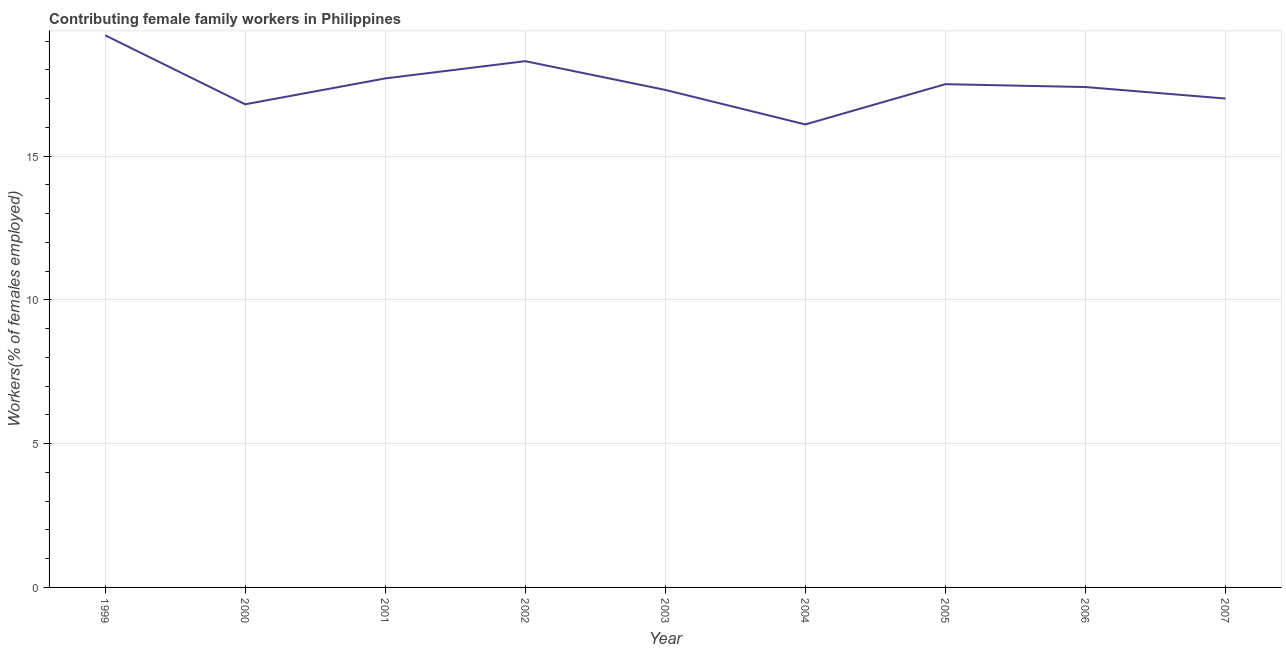What is the contributing female family workers in 2003?
Your answer should be compact. 17.3. Across all years, what is the maximum contributing female family workers?
Provide a short and direct response. 19.2. Across all years, what is the minimum contributing female family workers?
Keep it short and to the point. 16.1. What is the sum of the contributing female family workers?
Offer a very short reply. 157.3. What is the difference between the contributing female family workers in 2001 and 2004?
Offer a very short reply. 1.6. What is the average contributing female family workers per year?
Keep it short and to the point. 17.48. What is the median contributing female family workers?
Your response must be concise. 17.4. In how many years, is the contributing female family workers greater than 2 %?
Provide a short and direct response. 9. What is the ratio of the contributing female family workers in 2000 to that in 2007?
Your answer should be very brief. 0.99. Is the difference between the contributing female family workers in 2001 and 2004 greater than the difference between any two years?
Keep it short and to the point. No. What is the difference between the highest and the second highest contributing female family workers?
Your answer should be compact. 0.9. Is the sum of the contributing female family workers in 1999 and 2001 greater than the maximum contributing female family workers across all years?
Give a very brief answer. Yes. What is the difference between the highest and the lowest contributing female family workers?
Offer a terse response. 3.1. Are the values on the major ticks of Y-axis written in scientific E-notation?
Your answer should be very brief. No. Does the graph contain grids?
Your answer should be very brief. Yes. What is the title of the graph?
Offer a very short reply. Contributing female family workers in Philippines. What is the label or title of the X-axis?
Ensure brevity in your answer.  Year. What is the label or title of the Y-axis?
Ensure brevity in your answer.  Workers(% of females employed). What is the Workers(% of females employed) in 1999?
Make the answer very short. 19.2. What is the Workers(% of females employed) of 2000?
Keep it short and to the point. 16.8. What is the Workers(% of females employed) of 2001?
Ensure brevity in your answer.  17.7. What is the Workers(% of females employed) of 2002?
Ensure brevity in your answer.  18.3. What is the Workers(% of females employed) in 2003?
Offer a very short reply. 17.3. What is the Workers(% of females employed) in 2004?
Ensure brevity in your answer.  16.1. What is the Workers(% of females employed) in 2006?
Keep it short and to the point. 17.4. What is the Workers(% of females employed) of 2007?
Your response must be concise. 17. What is the difference between the Workers(% of females employed) in 1999 and 2000?
Provide a short and direct response. 2.4. What is the difference between the Workers(% of females employed) in 1999 and 2003?
Make the answer very short. 1.9. What is the difference between the Workers(% of females employed) in 1999 and 2005?
Provide a short and direct response. 1.7. What is the difference between the Workers(% of females employed) in 1999 and 2006?
Give a very brief answer. 1.8. What is the difference between the Workers(% of females employed) in 2000 and 2001?
Keep it short and to the point. -0.9. What is the difference between the Workers(% of females employed) in 2000 and 2002?
Ensure brevity in your answer.  -1.5. What is the difference between the Workers(% of females employed) in 2000 and 2003?
Offer a very short reply. -0.5. What is the difference between the Workers(% of females employed) in 2001 and 2006?
Give a very brief answer. 0.3. What is the difference between the Workers(% of females employed) in 2001 and 2007?
Your response must be concise. 0.7. What is the difference between the Workers(% of females employed) in 2002 and 2004?
Your answer should be very brief. 2.2. What is the difference between the Workers(% of females employed) in 2002 and 2006?
Offer a terse response. 0.9. What is the difference between the Workers(% of females employed) in 2002 and 2007?
Keep it short and to the point. 1.3. What is the difference between the Workers(% of females employed) in 2003 and 2005?
Make the answer very short. -0.2. What is the difference between the Workers(% of females employed) in 2003 and 2006?
Offer a terse response. -0.1. What is the difference between the Workers(% of females employed) in 2003 and 2007?
Make the answer very short. 0.3. What is the difference between the Workers(% of females employed) in 2004 and 2005?
Offer a terse response. -1.4. What is the difference between the Workers(% of females employed) in 2005 and 2006?
Your answer should be very brief. 0.1. What is the difference between the Workers(% of females employed) in 2006 and 2007?
Keep it short and to the point. 0.4. What is the ratio of the Workers(% of females employed) in 1999 to that in 2000?
Your answer should be very brief. 1.14. What is the ratio of the Workers(% of females employed) in 1999 to that in 2001?
Your answer should be compact. 1.08. What is the ratio of the Workers(% of females employed) in 1999 to that in 2002?
Your answer should be compact. 1.05. What is the ratio of the Workers(% of females employed) in 1999 to that in 2003?
Make the answer very short. 1.11. What is the ratio of the Workers(% of females employed) in 1999 to that in 2004?
Ensure brevity in your answer.  1.19. What is the ratio of the Workers(% of females employed) in 1999 to that in 2005?
Make the answer very short. 1.1. What is the ratio of the Workers(% of females employed) in 1999 to that in 2006?
Give a very brief answer. 1.1. What is the ratio of the Workers(% of females employed) in 1999 to that in 2007?
Offer a very short reply. 1.13. What is the ratio of the Workers(% of females employed) in 2000 to that in 2001?
Offer a very short reply. 0.95. What is the ratio of the Workers(% of females employed) in 2000 to that in 2002?
Provide a short and direct response. 0.92. What is the ratio of the Workers(% of females employed) in 2000 to that in 2003?
Give a very brief answer. 0.97. What is the ratio of the Workers(% of females employed) in 2000 to that in 2004?
Provide a succinct answer. 1.04. What is the ratio of the Workers(% of females employed) in 2001 to that in 2004?
Offer a terse response. 1.1. What is the ratio of the Workers(% of females employed) in 2001 to that in 2006?
Give a very brief answer. 1.02. What is the ratio of the Workers(% of females employed) in 2001 to that in 2007?
Offer a terse response. 1.04. What is the ratio of the Workers(% of females employed) in 2002 to that in 2003?
Offer a terse response. 1.06. What is the ratio of the Workers(% of females employed) in 2002 to that in 2004?
Your answer should be compact. 1.14. What is the ratio of the Workers(% of females employed) in 2002 to that in 2005?
Your answer should be very brief. 1.05. What is the ratio of the Workers(% of females employed) in 2002 to that in 2006?
Give a very brief answer. 1.05. What is the ratio of the Workers(% of females employed) in 2002 to that in 2007?
Your answer should be compact. 1.08. What is the ratio of the Workers(% of females employed) in 2003 to that in 2004?
Offer a terse response. 1.07. What is the ratio of the Workers(% of females employed) in 2003 to that in 2006?
Your response must be concise. 0.99. What is the ratio of the Workers(% of females employed) in 2003 to that in 2007?
Offer a very short reply. 1.02. What is the ratio of the Workers(% of females employed) in 2004 to that in 2005?
Your response must be concise. 0.92. What is the ratio of the Workers(% of females employed) in 2004 to that in 2006?
Give a very brief answer. 0.93. What is the ratio of the Workers(% of females employed) in 2004 to that in 2007?
Provide a succinct answer. 0.95. What is the ratio of the Workers(% of females employed) in 2006 to that in 2007?
Ensure brevity in your answer.  1.02. 